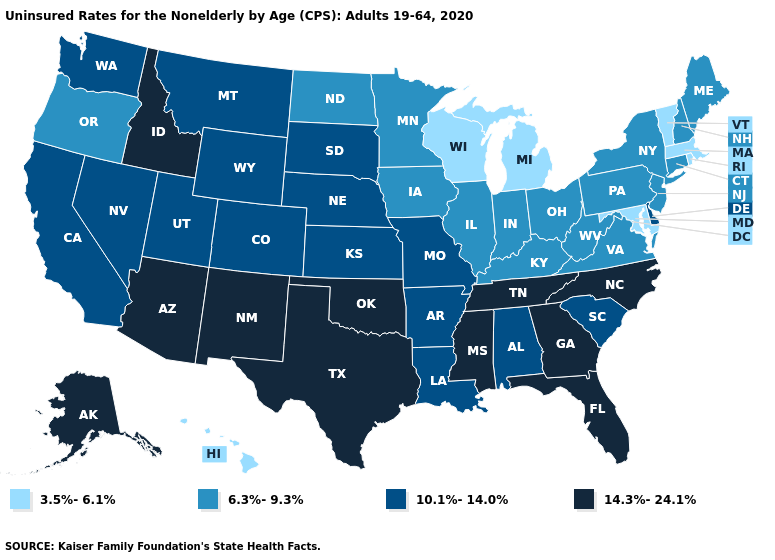What is the value of Maryland?
Answer briefly. 3.5%-6.1%. Among the states that border New Hampshire , which have the lowest value?
Write a very short answer. Massachusetts, Vermont. What is the highest value in the Northeast ?
Write a very short answer. 6.3%-9.3%. Among the states that border Connecticut , does Rhode Island have the highest value?
Give a very brief answer. No. What is the highest value in the West ?
Quick response, please. 14.3%-24.1%. Name the states that have a value in the range 10.1%-14.0%?
Be succinct. Alabama, Arkansas, California, Colorado, Delaware, Kansas, Louisiana, Missouri, Montana, Nebraska, Nevada, South Carolina, South Dakota, Utah, Washington, Wyoming. What is the lowest value in states that border Indiana?
Answer briefly. 3.5%-6.1%. Name the states that have a value in the range 10.1%-14.0%?
Be succinct. Alabama, Arkansas, California, Colorado, Delaware, Kansas, Louisiana, Missouri, Montana, Nebraska, Nevada, South Carolina, South Dakota, Utah, Washington, Wyoming. Does New Jersey have the lowest value in the USA?
Write a very short answer. No. Does Indiana have a lower value than Idaho?
Answer briefly. Yes. Does the first symbol in the legend represent the smallest category?
Short answer required. Yes. Among the states that border Pennsylvania , does New Jersey have the highest value?
Keep it brief. No. What is the value of West Virginia?
Give a very brief answer. 6.3%-9.3%. Name the states that have a value in the range 6.3%-9.3%?
Be succinct. Connecticut, Illinois, Indiana, Iowa, Kentucky, Maine, Minnesota, New Hampshire, New Jersey, New York, North Dakota, Ohio, Oregon, Pennsylvania, Virginia, West Virginia. Does Wisconsin have a lower value than Michigan?
Quick response, please. No. 